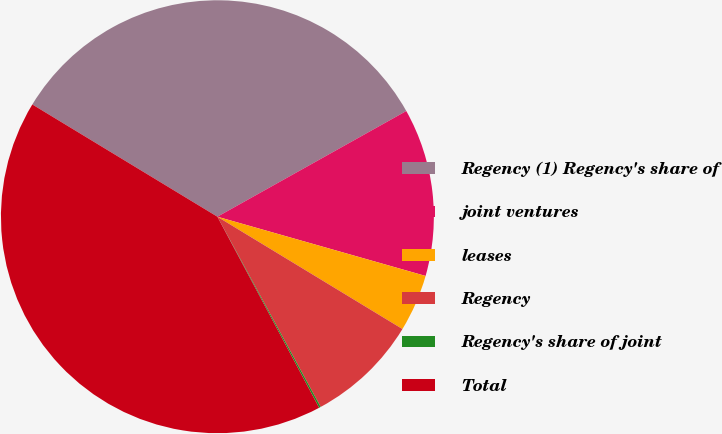Convert chart. <chart><loc_0><loc_0><loc_500><loc_500><pie_chart><fcel>Regency (1) Regency's share of<fcel>joint ventures<fcel>leases<fcel>Regency<fcel>Regency's share of joint<fcel>Total<nl><fcel>33.2%<fcel>12.53%<fcel>4.27%<fcel>8.4%<fcel>0.13%<fcel>41.46%<nl></chart> 